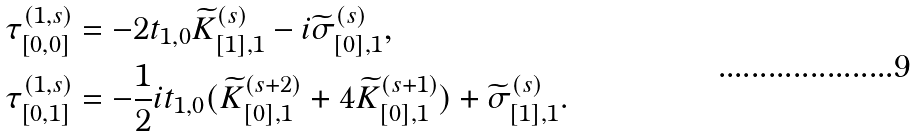<formula> <loc_0><loc_0><loc_500><loc_500>\tau ^ { ( 1 , s ) } _ { [ 0 , 0 ] } & = - 2 t _ { 1 , 0 } \widetilde { K } ^ { ( s ) } _ { [ 1 ] , 1 } - i \widetilde { \sigma } ^ { ( s ) } _ { [ 0 ] , 1 } , \\ \tau ^ { ( 1 , s ) } _ { [ 0 , 1 ] } & = - \frac { 1 } { 2 } i t _ { 1 , 0 } ( \widetilde { K } ^ { ( s + 2 ) } _ { [ 0 ] , 1 } + 4 \widetilde { K } ^ { ( s + 1 ) } _ { [ 0 ] , 1 } ) + \widetilde { \sigma } ^ { ( s ) } _ { [ 1 ] , 1 } .</formula> 